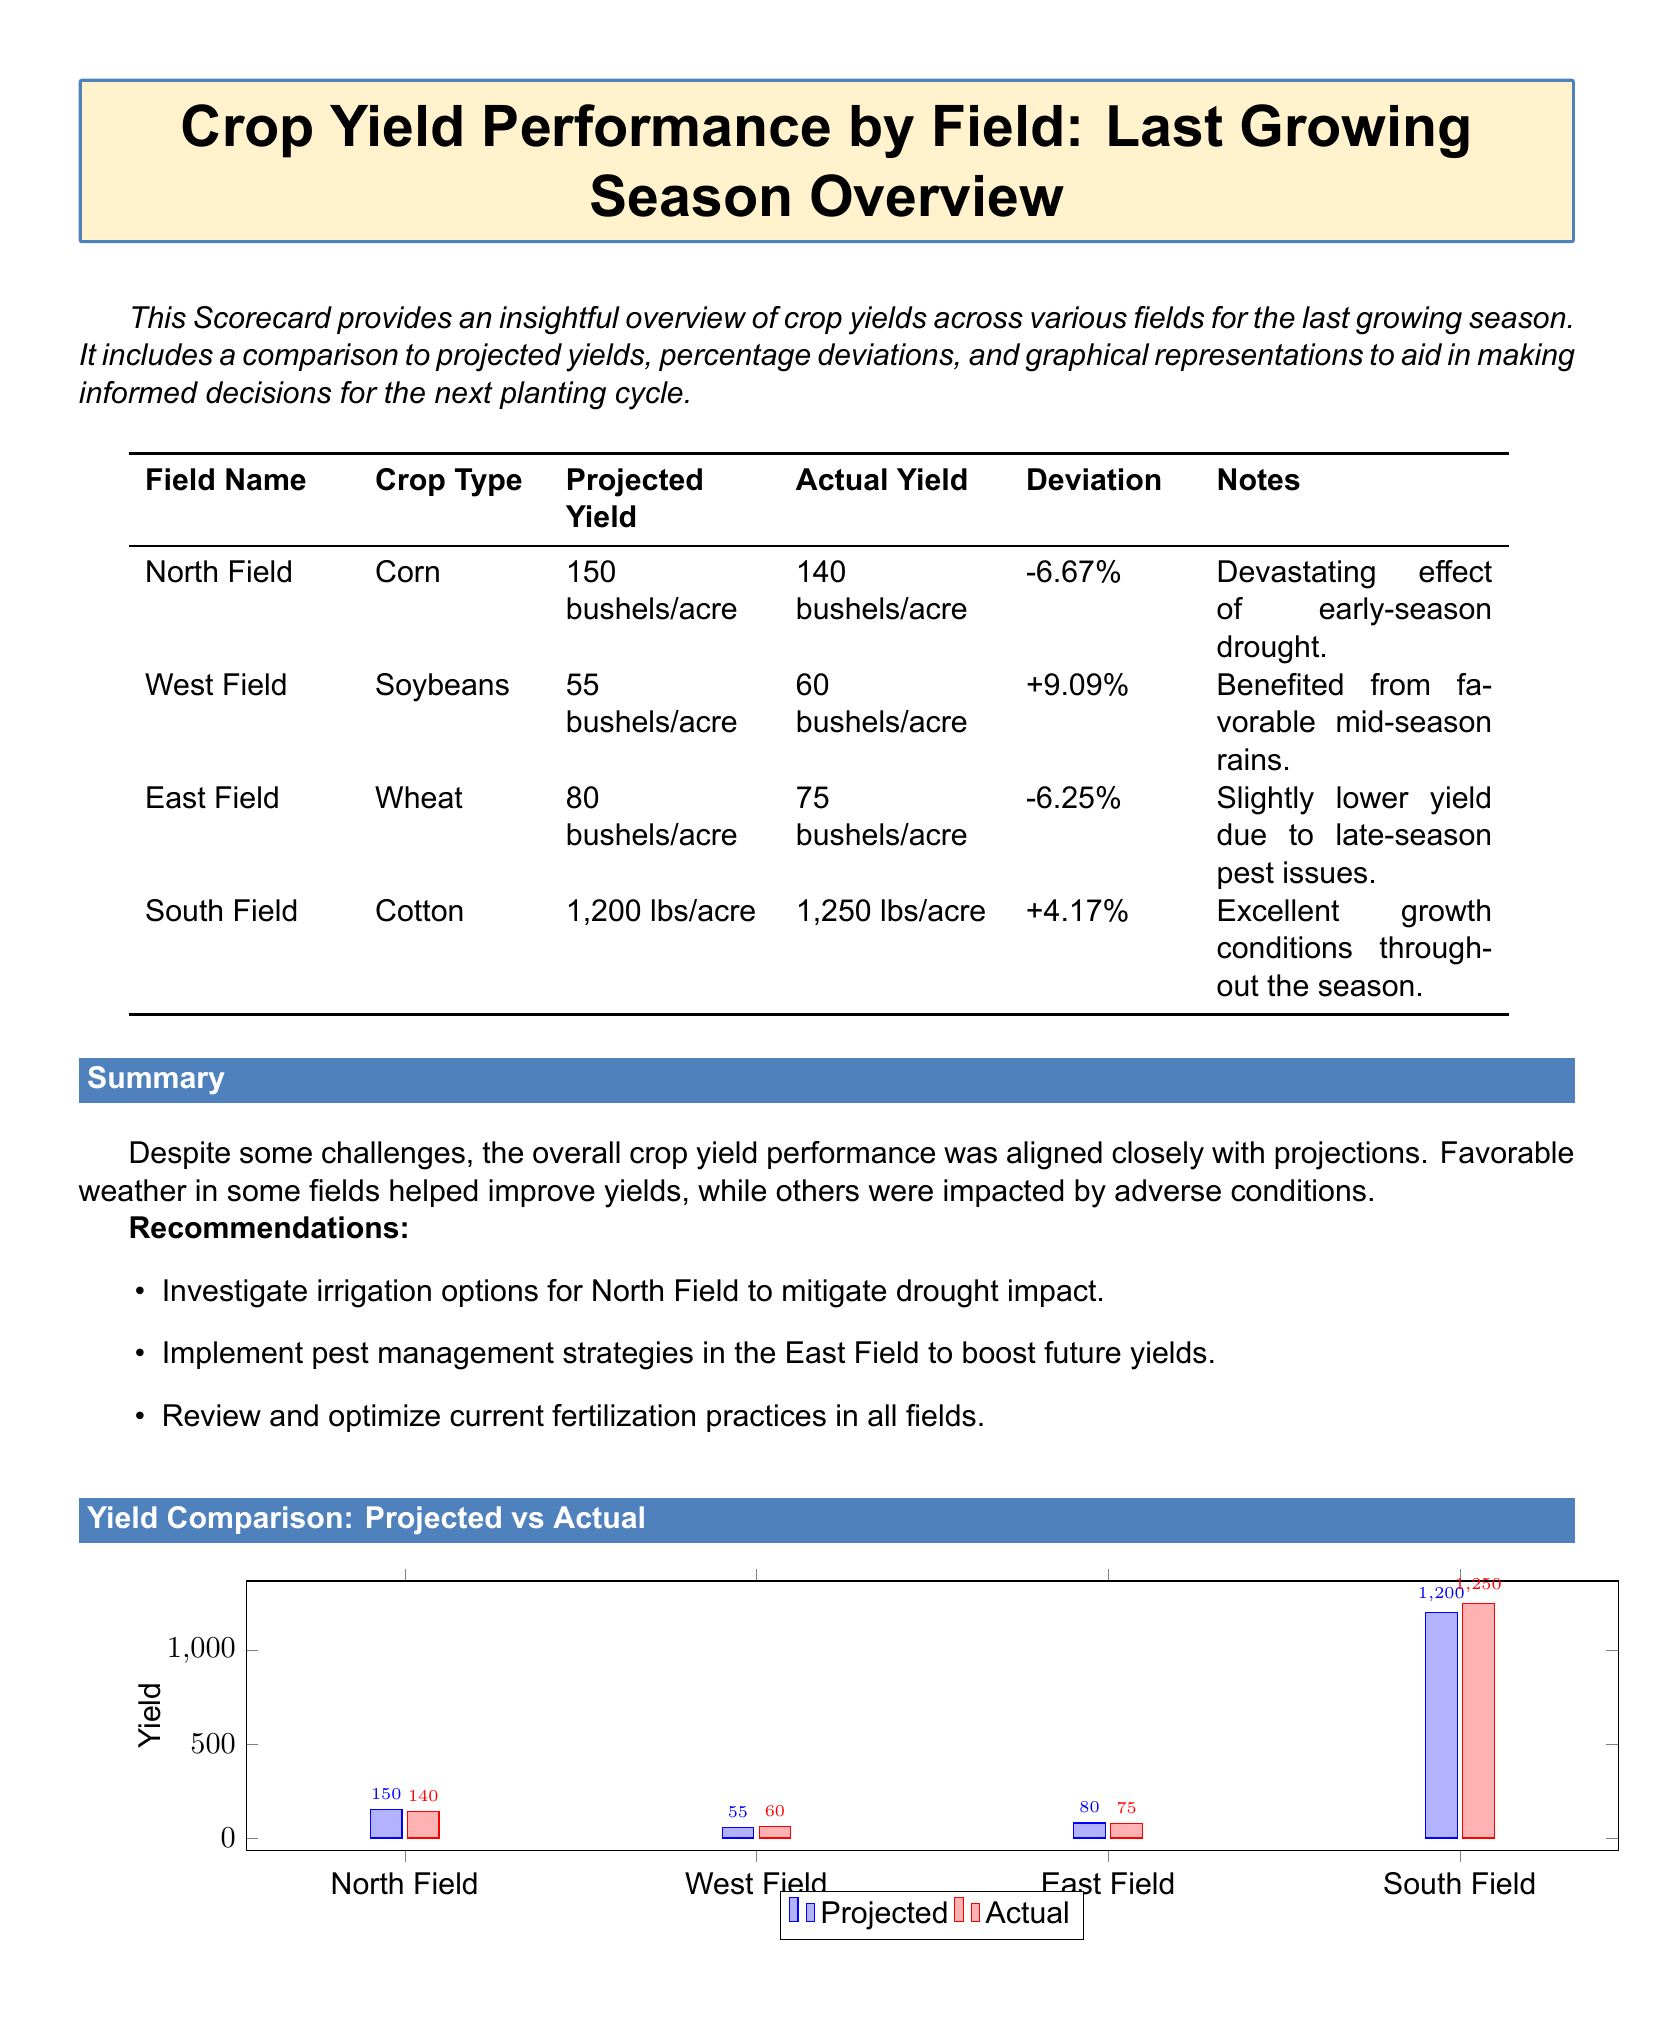What is the crop type in North Field? The document specifies the crop type for each field, including North Field, which is corn.
Answer: Corn What was the projected yield for West Field? The projected yield for each field is listed, with West Field projected at 55 bushels/acre.
Answer: 55 bushels/acre What percentage deviation did East Field experience? The percentage deviation is recorded for each field, indicating East Field had a deviation of -6.25%.
Answer: -6.25% Which field had the highest actual yield? By comparing the actual yields, it's evident that South Field had the highest yield at 1,250 lbs/acre.
Answer: 1,250 lbs/acre What is the main recommendation for North Field? The recommendations section provides actionable insights, suggesting investigating irrigation options for North Field.
Answer: Investigate irrigation options What affected the yield in East Field? The notes for each field outline factors impacting yields, with East Field affected by late-season pest issues.
Answer: Late-season pest issues Which field had the most favorable conditions leading to a yield increase? The document notes that South Field had excellent growth conditions throughout the season, contributing to a higher yield.
Answer: South Field What is the total projected yield for all fields combined? By adding the projected yields from each field, the total can be calculated: 150 + 55 + 80 + 1200 = 1485 bushels/acre.
Answer: 1485 bushels/acre What graphical representation is included in the document? The document includes a bar chart comparing projected and actual yields across the fields.
Answer: Bar chart 